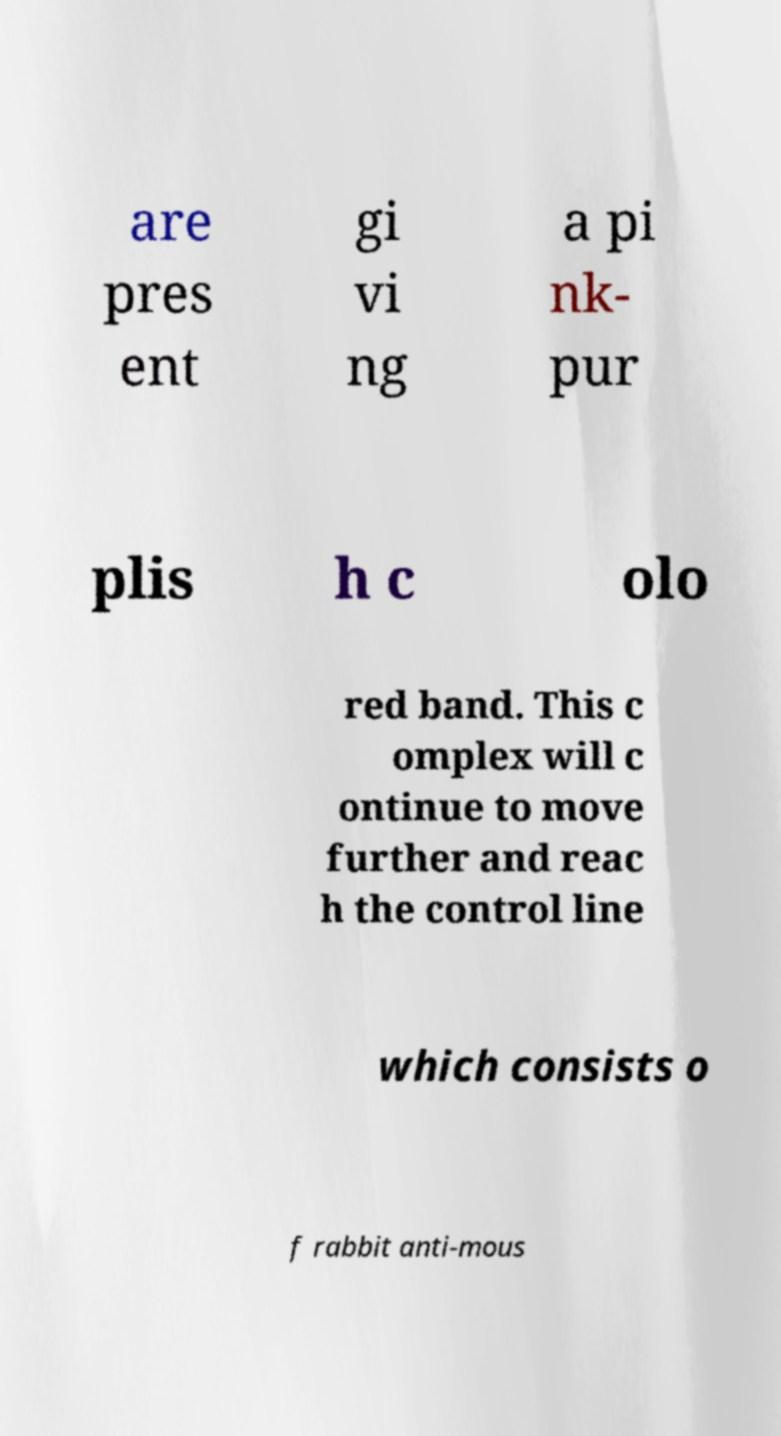Could you assist in decoding the text presented in this image and type it out clearly? are pres ent gi vi ng a pi nk- pur plis h c olo red band. This c omplex will c ontinue to move further and reac h the control line which consists o f rabbit anti-mous 